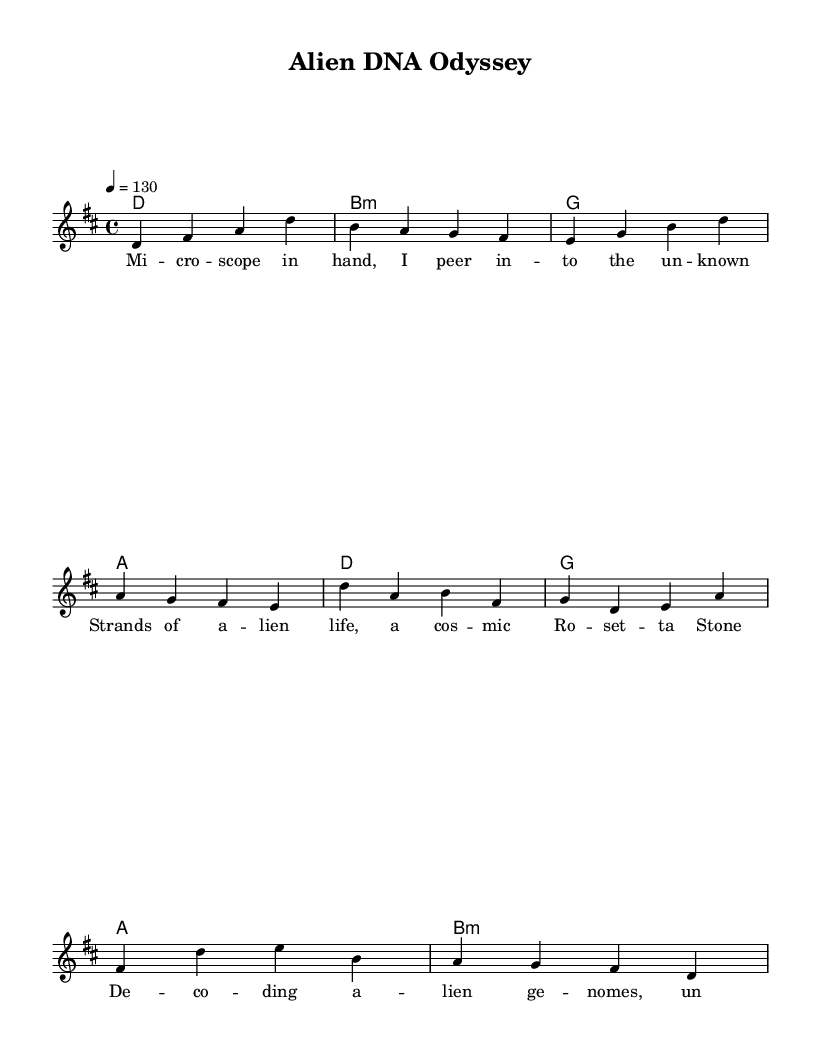What is the key signature of this music? The key signature is indicated at the beginning of the sheet music and is one sharp, which corresponds to D major.
Answer: D major What is the time signature of this song? The time signature is displayed at the beginning of the sheet music and shows four beats per measure.
Answer: 4/4 What is the tempo marking for this piece? The tempo is indicated in the tempo section, which shows the piece should be played at 130 beats per minute.
Answer: 130 How many measures are in the verse? By counting each complete set of notes and rests in the verse section, it is evident that there are four measures.
Answer: 4 What musical section follows the verse? The structure is shown in the layout of the sheet music; after the verse, the chorus follows immediately.
Answer: Chorus What harmony chord follows the first verse? The harmonies are listed underneath the verse section, showing the first chord after the verse is D major.
Answer: D major What themes are expressed in the lyrics? Analyzing the content of the lyrics shows that they explore themes of scientific discovery and alien life forms.
Answer: Scientific discovery and alien life 